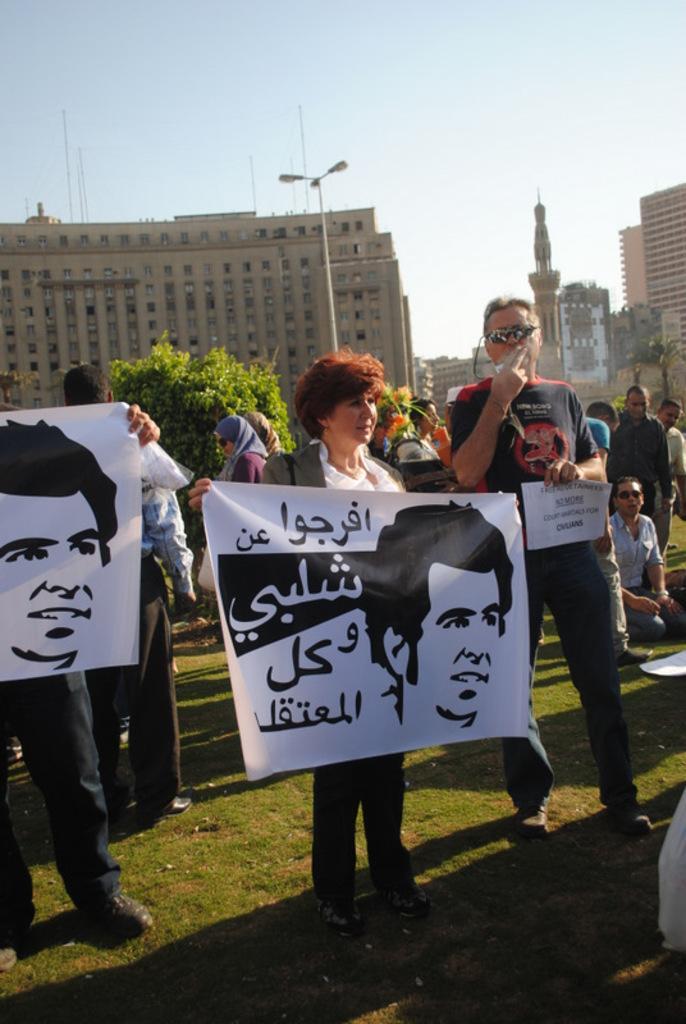In one or two sentences, can you explain what this image depicts? In the foreground of the picture there are people holding placards and there is grass at the bottom. In the center of the picture there are trees, street light and other objects. In the background there are buildings and sky. 